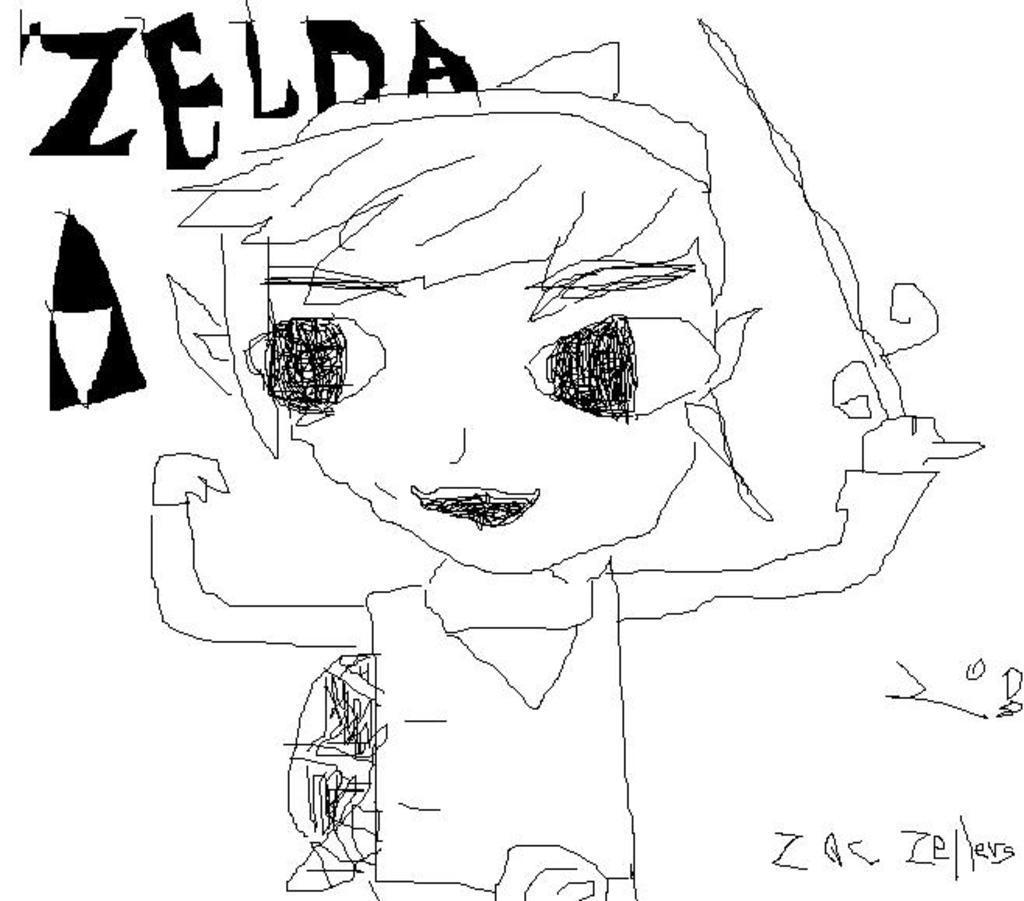Can you describe this image briefly? In this picture I can see there is a drawing of a boy and he is holding a object in his left hand and there is a tent and something written. The backdrop is a white surface. 